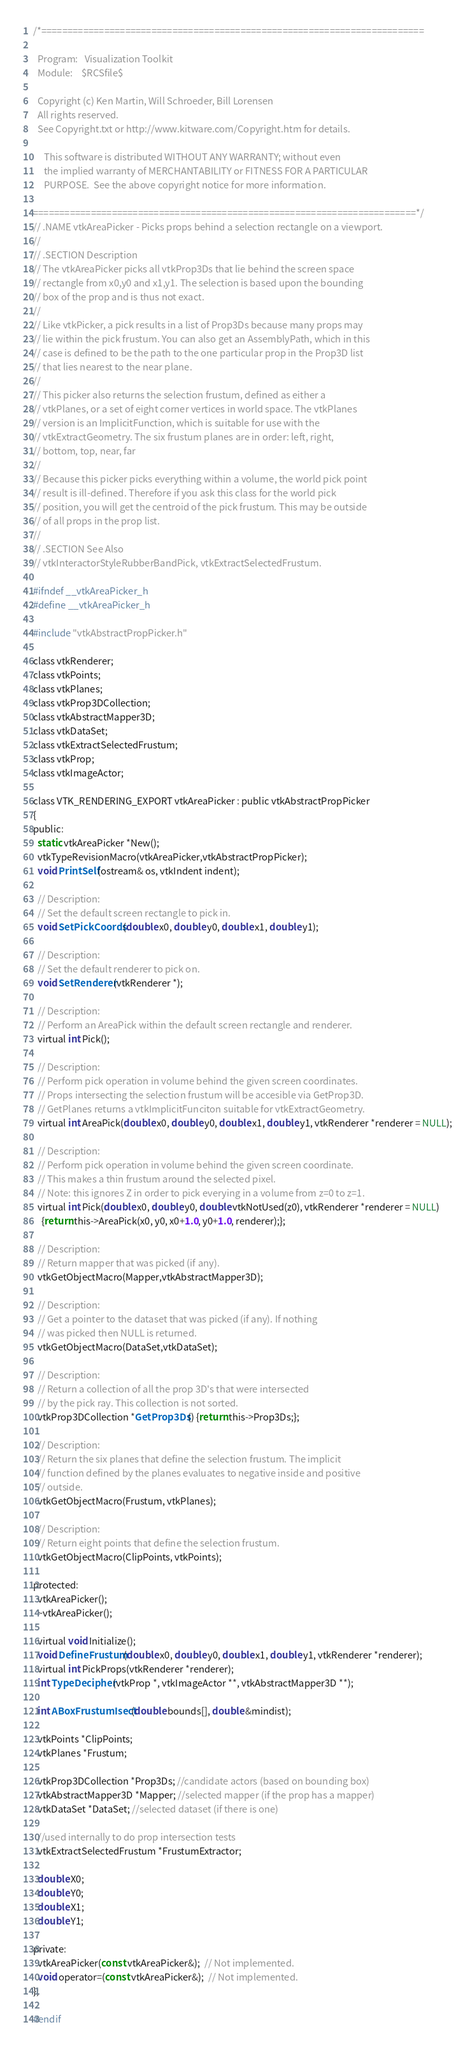<code> <loc_0><loc_0><loc_500><loc_500><_C_>/*=========================================================================

  Program:   Visualization Toolkit
  Module:    $RCSfile$

  Copyright (c) Ken Martin, Will Schroeder, Bill Lorensen
  All rights reserved.
  See Copyright.txt or http://www.kitware.com/Copyright.htm for details.

     This software is distributed WITHOUT ANY WARRANTY; without even
     the implied warranty of MERCHANTABILITY or FITNESS FOR A PARTICULAR
     PURPOSE.  See the above copyright notice for more information.

=========================================================================*/
// .NAME vtkAreaPicker - Picks props behind a selection rectangle on a viewport.
//
// .SECTION Description
// The vtkAreaPicker picks all vtkProp3Ds that lie behind the screen space 
// rectangle from x0,y0 and x1,y1. The selection is based upon the bounding
// box of the prop and is thus not exact.
//
// Like vtkPicker, a pick results in a list of Prop3Ds because many props may 
// lie within the pick frustum. You can also get an AssemblyPath, which in this
// case is defined to be the path to the one particular prop in the Prop3D list
// that lies nearest to the near plane. 
//
// This picker also returns the selection frustum, defined as either a
// vtkPlanes, or a set of eight corner vertices in world space. The vtkPlanes 
// version is an ImplicitFunction, which is suitable for use with the
// vtkExtractGeometry. The six frustum planes are in order: left, right, 
// bottom, top, near, far
//
// Because this picker picks everything within a volume, the world pick point 
// result is ill-defined. Therefore if you ask this class for the world pick 
// position, you will get the centroid of the pick frustum. This may be outside
// of all props in the prop list.
//
// .SECTION See Also
// vtkInteractorStyleRubberBandPick, vtkExtractSelectedFrustum.

#ifndef __vtkAreaPicker_h
#define __vtkAreaPicker_h

#include "vtkAbstractPropPicker.h"

class vtkRenderer;
class vtkPoints;
class vtkPlanes;
class vtkProp3DCollection;
class vtkAbstractMapper3D;
class vtkDataSet;
class vtkExtractSelectedFrustum;
class vtkProp;
class vtkImageActor;

class VTK_RENDERING_EXPORT vtkAreaPicker : public vtkAbstractPropPicker
{
public:
  static vtkAreaPicker *New();
  vtkTypeRevisionMacro(vtkAreaPicker,vtkAbstractPropPicker);
  void PrintSelf(ostream& os, vtkIndent indent);

  // Description:
  // Set the default screen rectangle to pick in.
  void SetPickCoords(double x0, double y0, double x1, double y1);
  
  // Description:
  // Set the default renderer to pick on.
  void SetRenderer(vtkRenderer *);

  // Description:
  // Perform an AreaPick within the default screen rectangle and renderer.
  virtual int Pick();

  // Description:
  // Perform pick operation in volume behind the given screen coordinates.
  // Props intersecting the selection frustum will be accesible via GetProp3D.
  // GetPlanes returns a vtkImplicitFunciton suitable for vtkExtractGeometry.
  virtual int AreaPick(double x0, double y0, double x1, double y1, vtkRenderer *renderer = NULL);

  // Description:
  // Perform pick operation in volume behind the given screen coordinate.
  // This makes a thin frustum around the selected pixel.
  // Note: this ignores Z in order to pick everying in a volume from z=0 to z=1.
  virtual int Pick(double x0, double y0, double vtkNotUsed(z0), vtkRenderer *renderer = NULL)
    {return this->AreaPick(x0, y0, x0+1.0, y0+1.0, renderer);};

  // Description:
  // Return mapper that was picked (if any).
  vtkGetObjectMacro(Mapper,vtkAbstractMapper3D);

  // Description:
  // Get a pointer to the dataset that was picked (if any). If nothing 
  // was picked then NULL is returned.
  vtkGetObjectMacro(DataSet,vtkDataSet);

  // Description:
  // Return a collection of all the prop 3D's that were intersected
  // by the pick ray. This collection is not sorted.
  vtkProp3DCollection *GetProp3Ds() {return this->Prop3Ds;};

  // Description:
  // Return the six planes that define the selection frustum. The implicit 
  // function defined by the planes evaluates to negative inside and positive
  // outside.
  vtkGetObjectMacro(Frustum, vtkPlanes);

  // Description:
  // Return eight points that define the selection frustum.
  vtkGetObjectMacro(ClipPoints, vtkPoints);

protected:
  vtkAreaPicker();
  ~vtkAreaPicker();

  virtual void Initialize();
  void DefineFrustum(double x0, double y0, double x1, double y1, vtkRenderer *renderer);
  virtual int PickProps(vtkRenderer *renderer);  
  int TypeDecipher(vtkProp *, vtkImageActor **, vtkAbstractMapper3D **);

  int ABoxFrustumIsect(double bounds[], double &mindist);

  vtkPoints *ClipPoints;
  vtkPlanes *Frustum;

  vtkProp3DCollection *Prop3Ds; //candidate actors (based on bounding box)
  vtkAbstractMapper3D *Mapper; //selected mapper (if the prop has a mapper)
  vtkDataSet *DataSet; //selected dataset (if there is one)

  //used internally to do prop intersection tests
  vtkExtractSelectedFrustum *FrustumExtractor;

  double X0;
  double Y0;
  double X1;
  double Y1;

private:
  vtkAreaPicker(const vtkAreaPicker&);  // Not implemented.
  void operator=(const vtkAreaPicker&);  // Not implemented.
};

#endif


</code> 